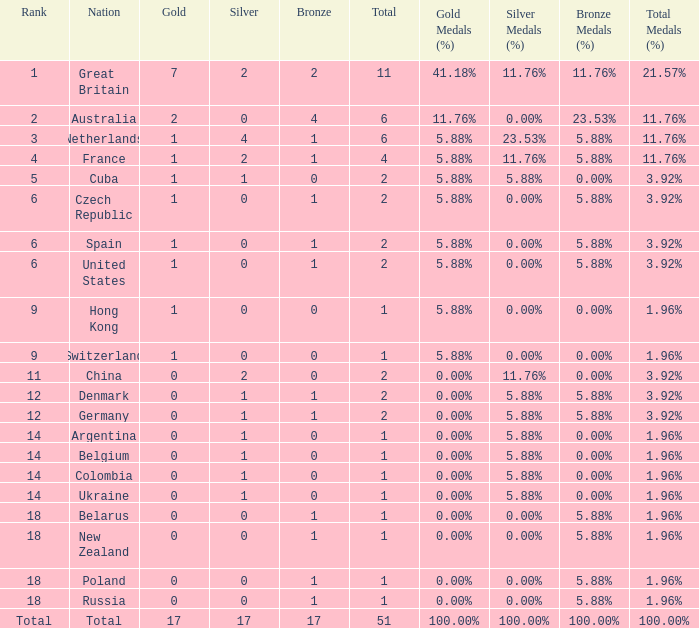Tell me the lowest gold for rank of 6 and total less than 2 None. 